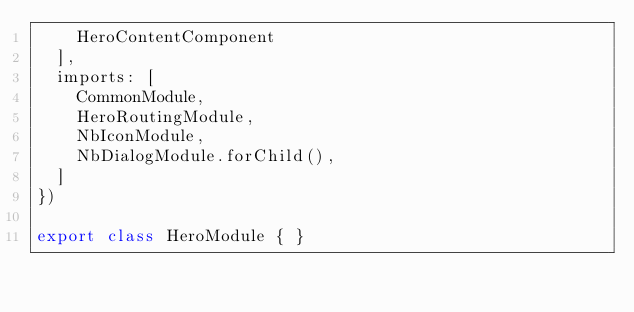<code> <loc_0><loc_0><loc_500><loc_500><_TypeScript_>    HeroContentComponent
  ],
  imports: [
    CommonModule,
    HeroRoutingModule,
    NbIconModule,
    NbDialogModule.forChild(),
  ]
})

export class HeroModule { }
</code> 